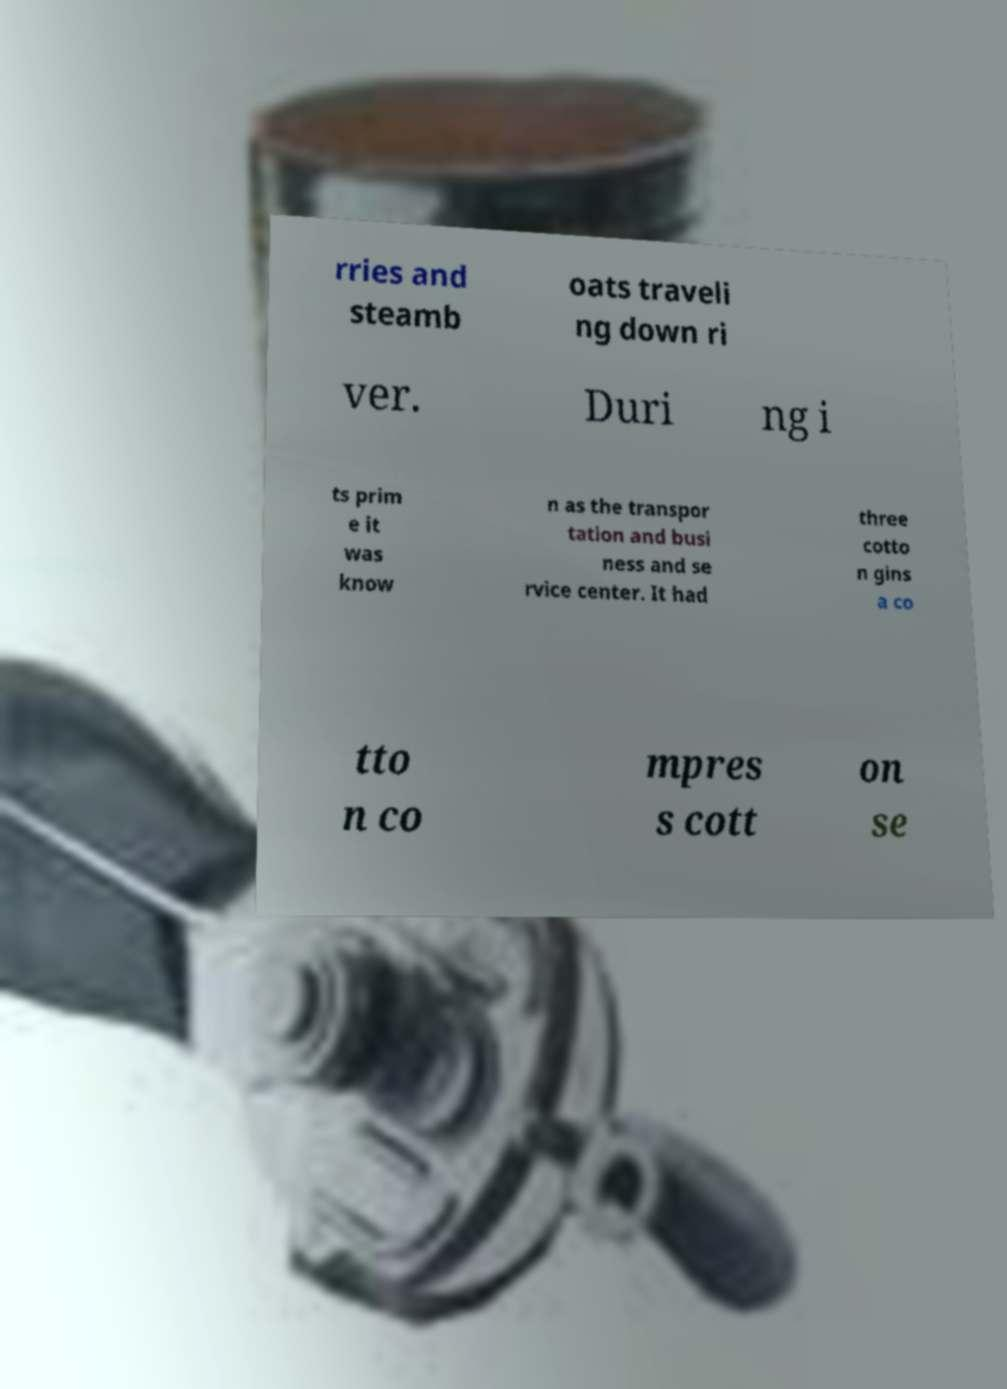Can you read and provide the text displayed in the image?This photo seems to have some interesting text. Can you extract and type it out for me? rries and steamb oats traveli ng down ri ver. Duri ng i ts prim e it was know n as the transpor tation and busi ness and se rvice center. It had three cotto n gins a co tto n co mpres s cott on se 